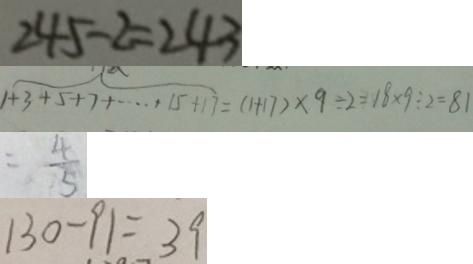Convert formula to latex. <formula><loc_0><loc_0><loc_500><loc_500>2 4 5 - 2 = 2 4 3 
 1 + 3 + 5 + 7 + \cdots + 1 5 + 1 7 = ( 1 + 1 7 ) \times 9 \div 2 = 1 8 \times 9 \div 2 = 8 1 
 = \frac { 4 } { 5 } 
 1 3 0 - 9 1 = 3 9</formula> 